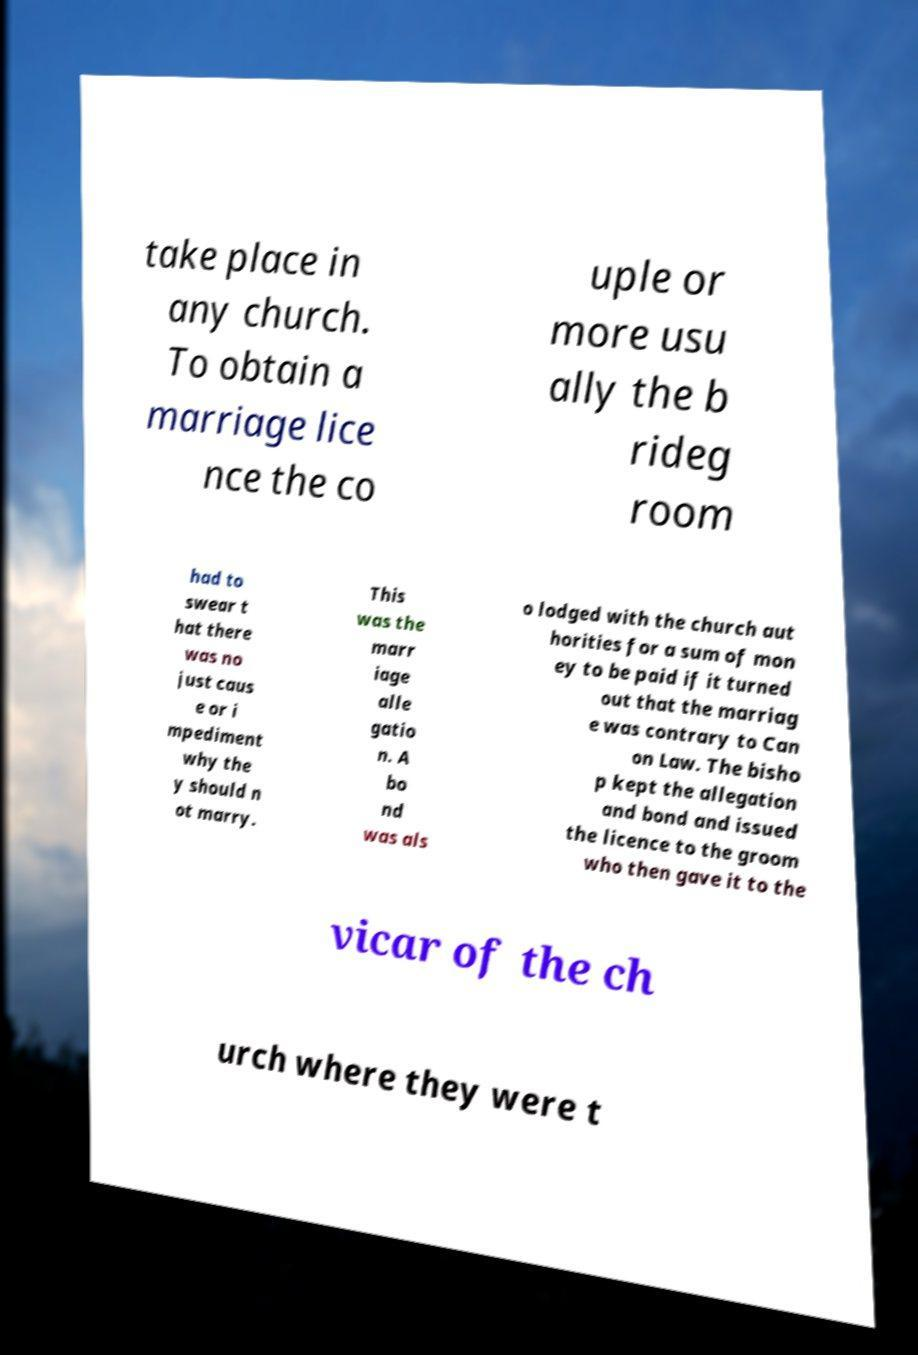What messages or text are displayed in this image? I need them in a readable, typed format. take place in any church. To obtain a marriage lice nce the co uple or more usu ally the b rideg room had to swear t hat there was no just caus e or i mpediment why the y should n ot marry. This was the marr iage alle gatio n. A bo nd was als o lodged with the church aut horities for a sum of mon ey to be paid if it turned out that the marriag e was contrary to Can on Law. The bisho p kept the allegation and bond and issued the licence to the groom who then gave it to the vicar of the ch urch where they were t 